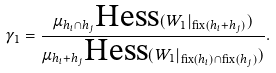Convert formula to latex. <formula><loc_0><loc_0><loc_500><loc_500>\gamma _ { 1 } = \frac { \mu _ { h _ { i } \cap h _ { j } } \text {Hess} ( W _ { 1 } | _ { \text {fix} ( h _ { i } + h _ { j } ) } ) } { \mu _ { h _ { i } + h _ { j } } \text {Hess} ( W _ { 1 } | _ { \text {fix} ( h _ { i } ) \cap \text {fix} ( h _ { j } ) } ) } .</formula> 